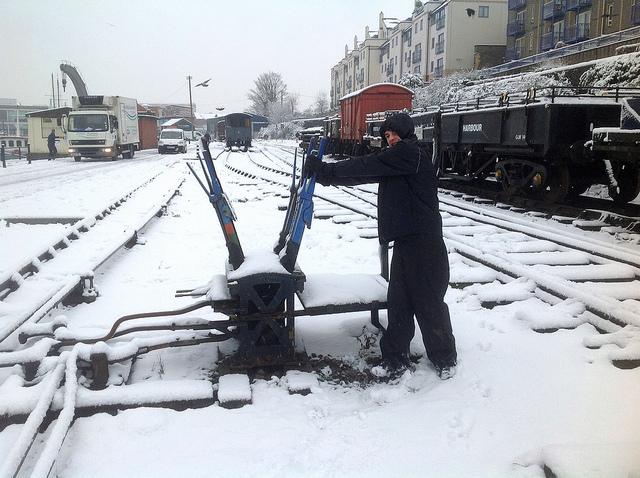What is the person wearing?
Short answer required. Snowsuit. Is the person looking at the camera?
Quick response, please. Yes. What is the weather like in this picture?
Answer briefly. Cold. Is this man mechanically controlling the tracks?
Be succinct. Yes. 